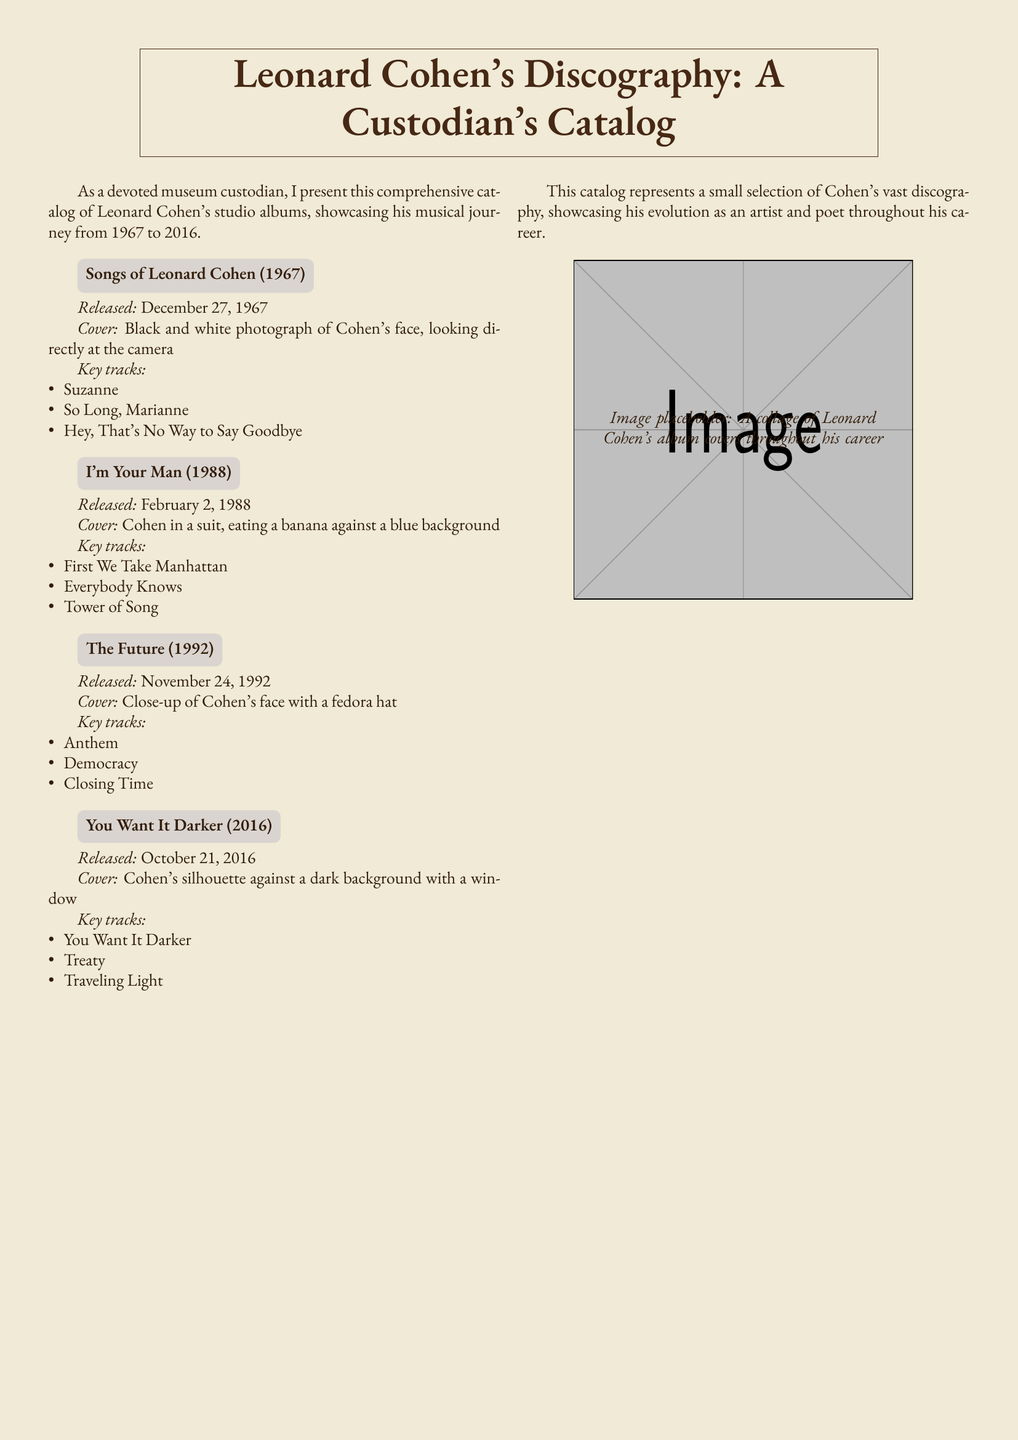What is the title of Leonard Cohen's first album? The first album listed in the catalog is "Songs of Leonard Cohen."
Answer: Songs of Leonard Cohen When was "I'm Your Man" released? The release date for "I'm Your Man" is provided in the catalog as February 2, 1988.
Answer: February 2, 1988 What are the key tracks from "The Future"? The catalog lists "Anthem," "Democracy," and "Closing Time" as key tracks of the album.
Answer: Anthem, Democracy, Closing Time Which album cover features Cohen eating a banana? The cover description mentions Cohen eating a banana; it belongs to "I'm Your Man."
Answer: I'm Your Man What shade is the background color of the document? The background color defined in the document is specified as RGB(240,234,214).
Answer: RGB(240,234,214) How many studio albums are mentioned in the catalog? The catalog contains detailed information about four studio albums by Leonard Cohen.
Answer: Four What is the release date of "You Want It Darker"? The release date provided in the catalog for this album is October 21, 2016.
Answer: October 21, 2016 Which key track is mentioned last for the album "You Want It Darker"? The last key track listed for this album in the catalog is "Traveling Light."
Answer: Traveling Light What visual element is included as a placeholder in the document? The document includes an image placeholder for a collage of Leonard Cohen's album covers.
Answer: A collage of album covers 